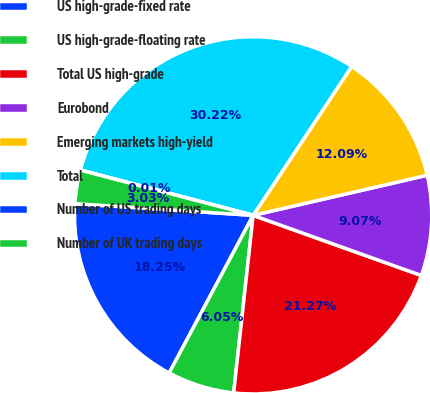<chart> <loc_0><loc_0><loc_500><loc_500><pie_chart><fcel>US high-grade-fixed rate<fcel>US high-grade-floating rate<fcel>Total US high-grade<fcel>Eurobond<fcel>Emerging markets high-yield<fcel>Total<fcel>Number of US trading days<fcel>Number of UK trading days<nl><fcel>18.25%<fcel>6.05%<fcel>21.27%<fcel>9.07%<fcel>12.09%<fcel>30.21%<fcel>0.01%<fcel>3.03%<nl></chart> 